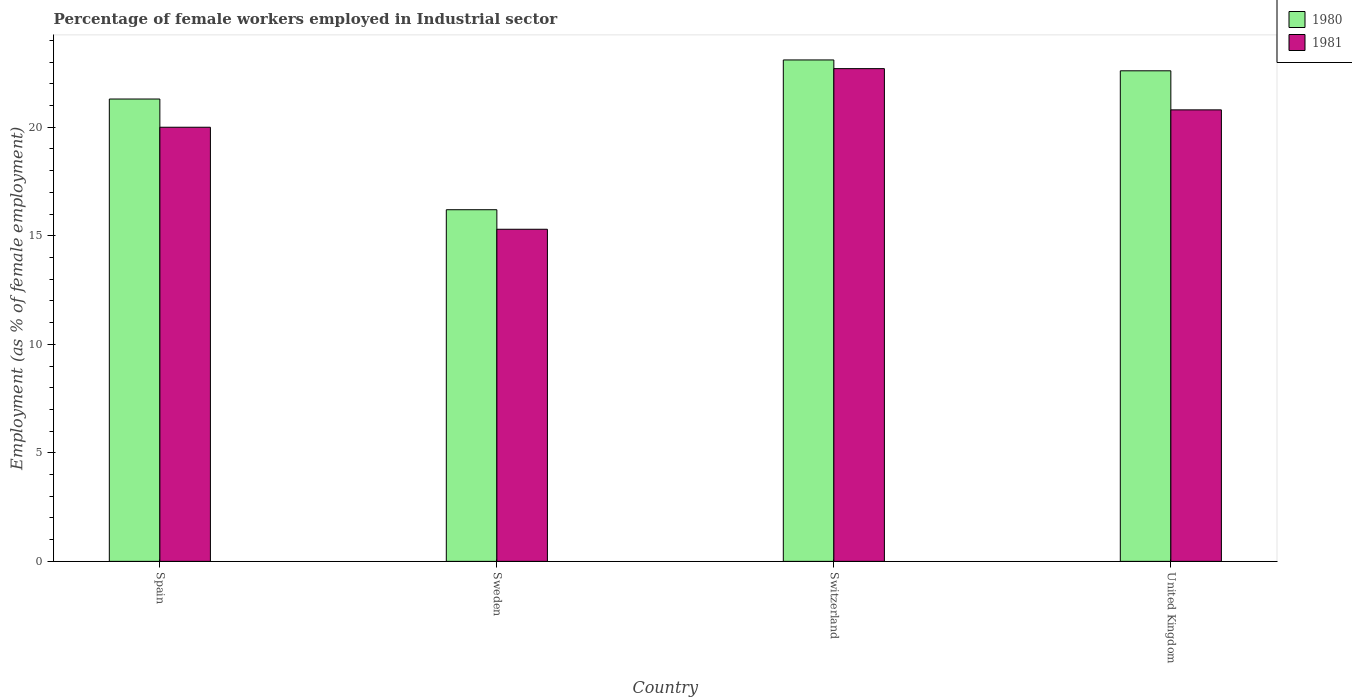How many groups of bars are there?
Offer a terse response. 4. Are the number of bars on each tick of the X-axis equal?
Offer a terse response. Yes. How many bars are there on the 3rd tick from the left?
Provide a succinct answer. 2. What is the label of the 4th group of bars from the left?
Your response must be concise. United Kingdom. What is the percentage of females employed in Industrial sector in 1980 in Spain?
Ensure brevity in your answer.  21.3. Across all countries, what is the maximum percentage of females employed in Industrial sector in 1980?
Keep it short and to the point. 23.1. Across all countries, what is the minimum percentage of females employed in Industrial sector in 1981?
Your answer should be compact. 15.3. In which country was the percentage of females employed in Industrial sector in 1981 maximum?
Provide a short and direct response. Switzerland. What is the total percentage of females employed in Industrial sector in 1981 in the graph?
Give a very brief answer. 78.8. What is the difference between the percentage of females employed in Industrial sector in 1980 in Sweden and that in United Kingdom?
Give a very brief answer. -6.4. What is the difference between the percentage of females employed in Industrial sector in 1980 in Sweden and the percentage of females employed in Industrial sector in 1981 in United Kingdom?
Provide a succinct answer. -4.6. What is the average percentage of females employed in Industrial sector in 1980 per country?
Give a very brief answer. 20.8. What is the difference between the percentage of females employed in Industrial sector of/in 1981 and percentage of females employed in Industrial sector of/in 1980 in United Kingdom?
Keep it short and to the point. -1.8. What is the ratio of the percentage of females employed in Industrial sector in 1980 in Spain to that in Switzerland?
Offer a very short reply. 0.92. Is the difference between the percentage of females employed in Industrial sector in 1981 in Spain and United Kingdom greater than the difference between the percentage of females employed in Industrial sector in 1980 in Spain and United Kingdom?
Make the answer very short. Yes. What is the difference between the highest and the second highest percentage of females employed in Industrial sector in 1981?
Give a very brief answer. 0.8. What is the difference between the highest and the lowest percentage of females employed in Industrial sector in 1980?
Give a very brief answer. 6.9. In how many countries, is the percentage of females employed in Industrial sector in 1981 greater than the average percentage of females employed in Industrial sector in 1981 taken over all countries?
Ensure brevity in your answer.  3. How many bars are there?
Give a very brief answer. 8. Are all the bars in the graph horizontal?
Make the answer very short. No. How many legend labels are there?
Your answer should be very brief. 2. What is the title of the graph?
Your response must be concise. Percentage of female workers employed in Industrial sector. Does "1993" appear as one of the legend labels in the graph?
Give a very brief answer. No. What is the label or title of the Y-axis?
Offer a terse response. Employment (as % of female employment). What is the Employment (as % of female employment) of 1980 in Spain?
Your response must be concise. 21.3. What is the Employment (as % of female employment) of 1980 in Sweden?
Ensure brevity in your answer.  16.2. What is the Employment (as % of female employment) in 1981 in Sweden?
Your answer should be compact. 15.3. What is the Employment (as % of female employment) of 1980 in Switzerland?
Your response must be concise. 23.1. What is the Employment (as % of female employment) in 1981 in Switzerland?
Your response must be concise. 22.7. What is the Employment (as % of female employment) of 1980 in United Kingdom?
Provide a short and direct response. 22.6. What is the Employment (as % of female employment) of 1981 in United Kingdom?
Give a very brief answer. 20.8. Across all countries, what is the maximum Employment (as % of female employment) in 1980?
Ensure brevity in your answer.  23.1. Across all countries, what is the maximum Employment (as % of female employment) in 1981?
Your answer should be very brief. 22.7. Across all countries, what is the minimum Employment (as % of female employment) in 1980?
Your answer should be compact. 16.2. Across all countries, what is the minimum Employment (as % of female employment) of 1981?
Ensure brevity in your answer.  15.3. What is the total Employment (as % of female employment) in 1980 in the graph?
Your answer should be compact. 83.2. What is the total Employment (as % of female employment) of 1981 in the graph?
Provide a short and direct response. 78.8. What is the difference between the Employment (as % of female employment) in 1980 in Spain and that in Switzerland?
Keep it short and to the point. -1.8. What is the difference between the Employment (as % of female employment) in 1981 in Spain and that in Switzerland?
Provide a short and direct response. -2.7. What is the difference between the Employment (as % of female employment) in 1981 in Spain and that in United Kingdom?
Keep it short and to the point. -0.8. What is the difference between the Employment (as % of female employment) of 1980 in Sweden and that in Switzerland?
Make the answer very short. -6.9. What is the difference between the Employment (as % of female employment) of 1981 in Sweden and that in United Kingdom?
Give a very brief answer. -5.5. What is the difference between the Employment (as % of female employment) in 1980 in Switzerland and that in United Kingdom?
Provide a succinct answer. 0.5. What is the difference between the Employment (as % of female employment) of 1981 in Switzerland and that in United Kingdom?
Offer a very short reply. 1.9. What is the difference between the Employment (as % of female employment) in 1980 in Spain and the Employment (as % of female employment) in 1981 in Switzerland?
Give a very brief answer. -1.4. What is the difference between the Employment (as % of female employment) of 1980 in Sweden and the Employment (as % of female employment) of 1981 in United Kingdom?
Offer a terse response. -4.6. What is the difference between the Employment (as % of female employment) of 1980 in Switzerland and the Employment (as % of female employment) of 1981 in United Kingdom?
Your answer should be very brief. 2.3. What is the average Employment (as % of female employment) in 1980 per country?
Provide a succinct answer. 20.8. What is the difference between the Employment (as % of female employment) of 1980 and Employment (as % of female employment) of 1981 in Spain?
Provide a succinct answer. 1.3. What is the difference between the Employment (as % of female employment) in 1980 and Employment (as % of female employment) in 1981 in Sweden?
Ensure brevity in your answer.  0.9. What is the ratio of the Employment (as % of female employment) in 1980 in Spain to that in Sweden?
Keep it short and to the point. 1.31. What is the ratio of the Employment (as % of female employment) of 1981 in Spain to that in Sweden?
Offer a very short reply. 1.31. What is the ratio of the Employment (as % of female employment) in 1980 in Spain to that in Switzerland?
Offer a very short reply. 0.92. What is the ratio of the Employment (as % of female employment) of 1981 in Spain to that in Switzerland?
Ensure brevity in your answer.  0.88. What is the ratio of the Employment (as % of female employment) in 1980 in Spain to that in United Kingdom?
Ensure brevity in your answer.  0.94. What is the ratio of the Employment (as % of female employment) of 1981 in Spain to that in United Kingdom?
Provide a succinct answer. 0.96. What is the ratio of the Employment (as % of female employment) of 1980 in Sweden to that in Switzerland?
Give a very brief answer. 0.7. What is the ratio of the Employment (as % of female employment) of 1981 in Sweden to that in Switzerland?
Offer a very short reply. 0.67. What is the ratio of the Employment (as % of female employment) of 1980 in Sweden to that in United Kingdom?
Offer a terse response. 0.72. What is the ratio of the Employment (as % of female employment) in 1981 in Sweden to that in United Kingdom?
Ensure brevity in your answer.  0.74. What is the ratio of the Employment (as % of female employment) in 1980 in Switzerland to that in United Kingdom?
Provide a succinct answer. 1.02. What is the ratio of the Employment (as % of female employment) in 1981 in Switzerland to that in United Kingdom?
Ensure brevity in your answer.  1.09. What is the difference between the highest and the lowest Employment (as % of female employment) of 1980?
Keep it short and to the point. 6.9. 